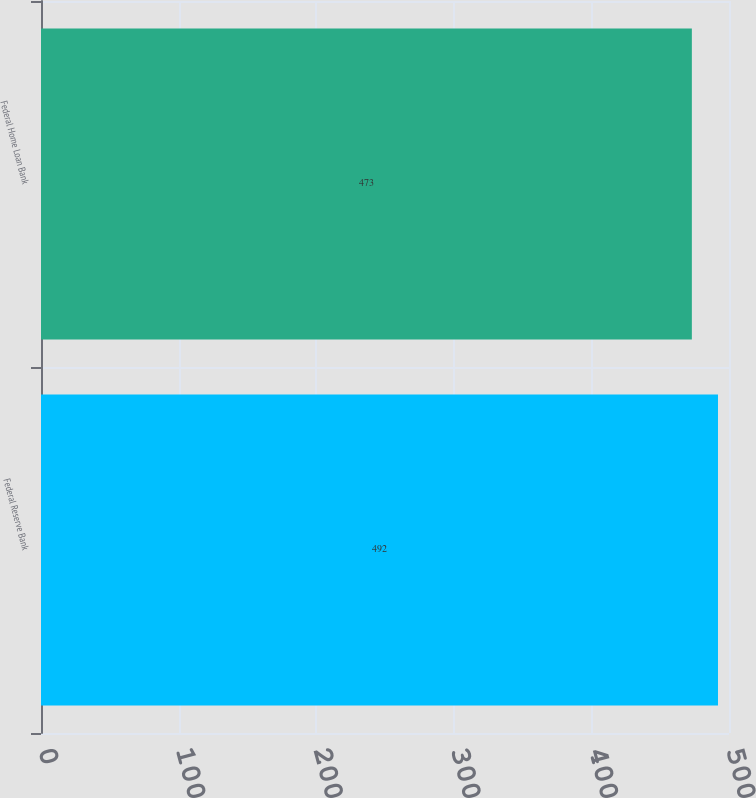Convert chart. <chart><loc_0><loc_0><loc_500><loc_500><bar_chart><fcel>Federal Reserve Bank<fcel>Federal Home Loan Bank<nl><fcel>492<fcel>473<nl></chart> 